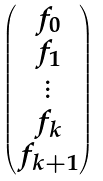Convert formula to latex. <formula><loc_0><loc_0><loc_500><loc_500>\begin{pmatrix} f _ { 0 } \\ f _ { 1 } \\ \vdots \\ f _ { k } \\ f _ { k + 1 } \end{pmatrix}</formula> 